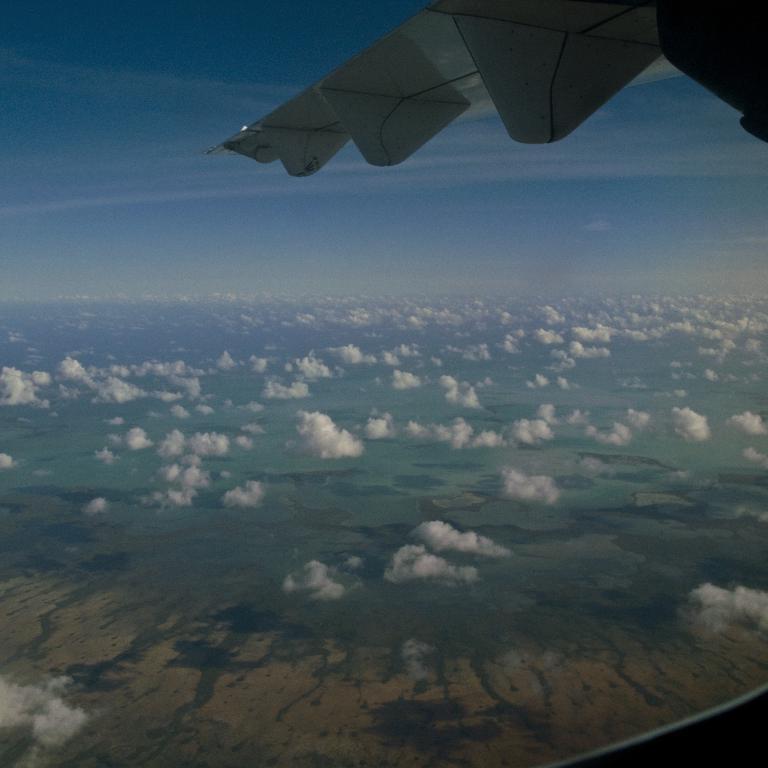Please provide a concise description of this image. In this image there is a flying flight above the clouds, under that there is some land. 